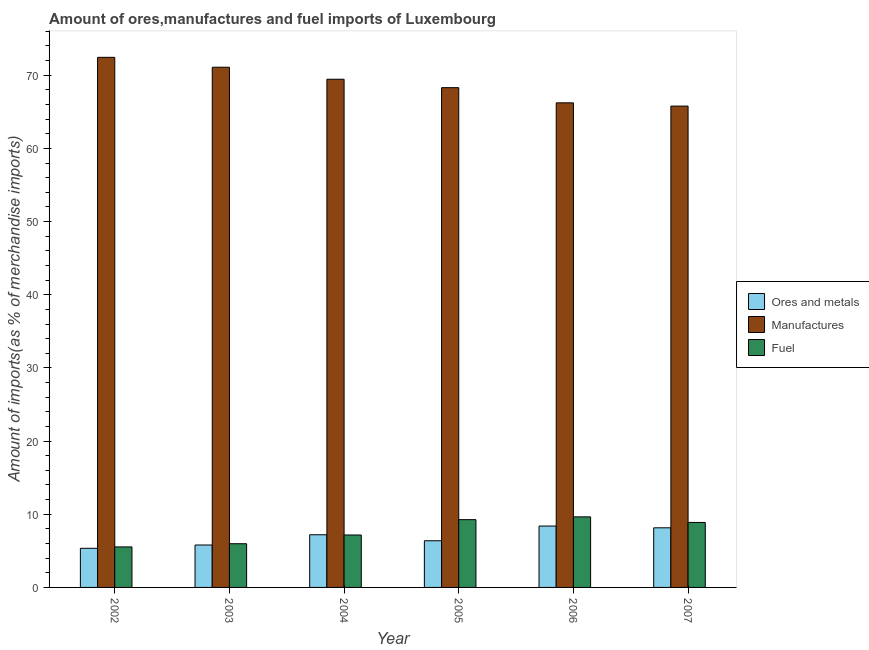How many different coloured bars are there?
Your answer should be very brief. 3. Are the number of bars per tick equal to the number of legend labels?
Your response must be concise. Yes. Are the number of bars on each tick of the X-axis equal?
Provide a short and direct response. Yes. How many bars are there on the 3rd tick from the left?
Offer a terse response. 3. How many bars are there on the 1st tick from the right?
Provide a succinct answer. 3. What is the percentage of manufactures imports in 2002?
Make the answer very short. 72.45. Across all years, what is the maximum percentage of manufactures imports?
Your response must be concise. 72.45. Across all years, what is the minimum percentage of manufactures imports?
Ensure brevity in your answer.  65.79. In which year was the percentage of ores and metals imports maximum?
Your answer should be compact. 2006. In which year was the percentage of ores and metals imports minimum?
Your answer should be compact. 2002. What is the total percentage of manufactures imports in the graph?
Ensure brevity in your answer.  413.32. What is the difference between the percentage of ores and metals imports in 2004 and that in 2006?
Make the answer very short. -1.19. What is the difference between the percentage of ores and metals imports in 2006 and the percentage of manufactures imports in 2004?
Offer a very short reply. 1.19. What is the average percentage of manufactures imports per year?
Your answer should be very brief. 68.89. What is the ratio of the percentage of fuel imports in 2003 to that in 2005?
Keep it short and to the point. 0.64. Is the percentage of ores and metals imports in 2004 less than that in 2007?
Keep it short and to the point. Yes. What is the difference between the highest and the second highest percentage of ores and metals imports?
Provide a short and direct response. 0.24. What is the difference between the highest and the lowest percentage of ores and metals imports?
Make the answer very short. 3.04. In how many years, is the percentage of ores and metals imports greater than the average percentage of ores and metals imports taken over all years?
Offer a terse response. 3. What does the 1st bar from the left in 2004 represents?
Make the answer very short. Ores and metals. What does the 1st bar from the right in 2004 represents?
Offer a terse response. Fuel. Are all the bars in the graph horizontal?
Your answer should be compact. No. Are the values on the major ticks of Y-axis written in scientific E-notation?
Offer a very short reply. No. Where does the legend appear in the graph?
Offer a terse response. Center right. How many legend labels are there?
Provide a succinct answer. 3. What is the title of the graph?
Offer a very short reply. Amount of ores,manufactures and fuel imports of Luxembourg. What is the label or title of the Y-axis?
Provide a short and direct response. Amount of imports(as % of merchandise imports). What is the Amount of imports(as % of merchandise imports) of Ores and metals in 2002?
Offer a very short reply. 5.35. What is the Amount of imports(as % of merchandise imports) of Manufactures in 2002?
Provide a succinct answer. 72.45. What is the Amount of imports(as % of merchandise imports) of Fuel in 2002?
Ensure brevity in your answer.  5.54. What is the Amount of imports(as % of merchandise imports) in Ores and metals in 2003?
Offer a terse response. 5.8. What is the Amount of imports(as % of merchandise imports) in Manufactures in 2003?
Offer a very short reply. 71.1. What is the Amount of imports(as % of merchandise imports) in Fuel in 2003?
Provide a succinct answer. 5.97. What is the Amount of imports(as % of merchandise imports) in Ores and metals in 2004?
Provide a short and direct response. 7.2. What is the Amount of imports(as % of merchandise imports) of Manufactures in 2004?
Your answer should be compact. 69.45. What is the Amount of imports(as % of merchandise imports) in Fuel in 2004?
Your response must be concise. 7.17. What is the Amount of imports(as % of merchandise imports) in Ores and metals in 2005?
Ensure brevity in your answer.  6.38. What is the Amount of imports(as % of merchandise imports) of Manufactures in 2005?
Offer a terse response. 68.3. What is the Amount of imports(as % of merchandise imports) of Fuel in 2005?
Your answer should be compact. 9.26. What is the Amount of imports(as % of merchandise imports) in Ores and metals in 2006?
Provide a short and direct response. 8.39. What is the Amount of imports(as % of merchandise imports) in Manufactures in 2006?
Your answer should be very brief. 66.23. What is the Amount of imports(as % of merchandise imports) of Fuel in 2006?
Provide a succinct answer. 9.64. What is the Amount of imports(as % of merchandise imports) of Ores and metals in 2007?
Keep it short and to the point. 8.15. What is the Amount of imports(as % of merchandise imports) in Manufactures in 2007?
Your response must be concise. 65.79. What is the Amount of imports(as % of merchandise imports) of Fuel in 2007?
Give a very brief answer. 8.88. Across all years, what is the maximum Amount of imports(as % of merchandise imports) of Ores and metals?
Keep it short and to the point. 8.39. Across all years, what is the maximum Amount of imports(as % of merchandise imports) in Manufactures?
Your response must be concise. 72.45. Across all years, what is the maximum Amount of imports(as % of merchandise imports) of Fuel?
Offer a very short reply. 9.64. Across all years, what is the minimum Amount of imports(as % of merchandise imports) of Ores and metals?
Your answer should be compact. 5.35. Across all years, what is the minimum Amount of imports(as % of merchandise imports) in Manufactures?
Make the answer very short. 65.79. Across all years, what is the minimum Amount of imports(as % of merchandise imports) of Fuel?
Make the answer very short. 5.54. What is the total Amount of imports(as % of merchandise imports) of Ores and metals in the graph?
Provide a succinct answer. 41.26. What is the total Amount of imports(as % of merchandise imports) in Manufactures in the graph?
Offer a terse response. 413.32. What is the total Amount of imports(as % of merchandise imports) in Fuel in the graph?
Give a very brief answer. 46.47. What is the difference between the Amount of imports(as % of merchandise imports) in Ores and metals in 2002 and that in 2003?
Your answer should be compact. -0.45. What is the difference between the Amount of imports(as % of merchandise imports) of Manufactures in 2002 and that in 2003?
Your answer should be compact. 1.35. What is the difference between the Amount of imports(as % of merchandise imports) in Fuel in 2002 and that in 2003?
Your answer should be compact. -0.44. What is the difference between the Amount of imports(as % of merchandise imports) of Ores and metals in 2002 and that in 2004?
Provide a short and direct response. -1.85. What is the difference between the Amount of imports(as % of merchandise imports) in Manufactures in 2002 and that in 2004?
Give a very brief answer. 2.99. What is the difference between the Amount of imports(as % of merchandise imports) of Fuel in 2002 and that in 2004?
Give a very brief answer. -1.63. What is the difference between the Amount of imports(as % of merchandise imports) in Ores and metals in 2002 and that in 2005?
Make the answer very short. -1.03. What is the difference between the Amount of imports(as % of merchandise imports) in Manufactures in 2002 and that in 2005?
Provide a short and direct response. 4.15. What is the difference between the Amount of imports(as % of merchandise imports) of Fuel in 2002 and that in 2005?
Your answer should be very brief. -3.73. What is the difference between the Amount of imports(as % of merchandise imports) of Ores and metals in 2002 and that in 2006?
Make the answer very short. -3.04. What is the difference between the Amount of imports(as % of merchandise imports) in Manufactures in 2002 and that in 2006?
Make the answer very short. 6.22. What is the difference between the Amount of imports(as % of merchandise imports) of Fuel in 2002 and that in 2006?
Provide a succinct answer. -4.11. What is the difference between the Amount of imports(as % of merchandise imports) of Ores and metals in 2002 and that in 2007?
Keep it short and to the point. -2.8. What is the difference between the Amount of imports(as % of merchandise imports) in Manufactures in 2002 and that in 2007?
Ensure brevity in your answer.  6.66. What is the difference between the Amount of imports(as % of merchandise imports) of Fuel in 2002 and that in 2007?
Offer a terse response. -3.34. What is the difference between the Amount of imports(as % of merchandise imports) in Ores and metals in 2003 and that in 2004?
Make the answer very short. -1.4. What is the difference between the Amount of imports(as % of merchandise imports) in Manufactures in 2003 and that in 2004?
Keep it short and to the point. 1.64. What is the difference between the Amount of imports(as % of merchandise imports) of Fuel in 2003 and that in 2004?
Your answer should be very brief. -1.19. What is the difference between the Amount of imports(as % of merchandise imports) in Ores and metals in 2003 and that in 2005?
Keep it short and to the point. -0.58. What is the difference between the Amount of imports(as % of merchandise imports) in Manufactures in 2003 and that in 2005?
Make the answer very short. 2.79. What is the difference between the Amount of imports(as % of merchandise imports) of Fuel in 2003 and that in 2005?
Offer a very short reply. -3.29. What is the difference between the Amount of imports(as % of merchandise imports) of Ores and metals in 2003 and that in 2006?
Offer a terse response. -2.59. What is the difference between the Amount of imports(as % of merchandise imports) of Manufactures in 2003 and that in 2006?
Offer a very short reply. 4.87. What is the difference between the Amount of imports(as % of merchandise imports) of Fuel in 2003 and that in 2006?
Make the answer very short. -3.67. What is the difference between the Amount of imports(as % of merchandise imports) of Ores and metals in 2003 and that in 2007?
Offer a terse response. -2.35. What is the difference between the Amount of imports(as % of merchandise imports) of Manufactures in 2003 and that in 2007?
Offer a terse response. 5.31. What is the difference between the Amount of imports(as % of merchandise imports) of Fuel in 2003 and that in 2007?
Provide a succinct answer. -2.91. What is the difference between the Amount of imports(as % of merchandise imports) in Ores and metals in 2004 and that in 2005?
Your answer should be compact. 0.82. What is the difference between the Amount of imports(as % of merchandise imports) in Manufactures in 2004 and that in 2005?
Your response must be concise. 1.15. What is the difference between the Amount of imports(as % of merchandise imports) in Fuel in 2004 and that in 2005?
Your answer should be very brief. -2.1. What is the difference between the Amount of imports(as % of merchandise imports) of Ores and metals in 2004 and that in 2006?
Offer a very short reply. -1.19. What is the difference between the Amount of imports(as % of merchandise imports) of Manufactures in 2004 and that in 2006?
Give a very brief answer. 3.22. What is the difference between the Amount of imports(as % of merchandise imports) in Fuel in 2004 and that in 2006?
Offer a very short reply. -2.48. What is the difference between the Amount of imports(as % of merchandise imports) of Ores and metals in 2004 and that in 2007?
Offer a very short reply. -0.95. What is the difference between the Amount of imports(as % of merchandise imports) of Manufactures in 2004 and that in 2007?
Keep it short and to the point. 3.67. What is the difference between the Amount of imports(as % of merchandise imports) in Fuel in 2004 and that in 2007?
Ensure brevity in your answer.  -1.71. What is the difference between the Amount of imports(as % of merchandise imports) in Ores and metals in 2005 and that in 2006?
Your response must be concise. -2.01. What is the difference between the Amount of imports(as % of merchandise imports) in Manufactures in 2005 and that in 2006?
Your answer should be compact. 2.07. What is the difference between the Amount of imports(as % of merchandise imports) in Fuel in 2005 and that in 2006?
Provide a short and direct response. -0.38. What is the difference between the Amount of imports(as % of merchandise imports) of Ores and metals in 2005 and that in 2007?
Your answer should be compact. -1.77. What is the difference between the Amount of imports(as % of merchandise imports) in Manufactures in 2005 and that in 2007?
Your response must be concise. 2.52. What is the difference between the Amount of imports(as % of merchandise imports) in Fuel in 2005 and that in 2007?
Provide a short and direct response. 0.38. What is the difference between the Amount of imports(as % of merchandise imports) in Ores and metals in 2006 and that in 2007?
Provide a succinct answer. 0.24. What is the difference between the Amount of imports(as % of merchandise imports) in Manufactures in 2006 and that in 2007?
Your response must be concise. 0.44. What is the difference between the Amount of imports(as % of merchandise imports) of Fuel in 2006 and that in 2007?
Ensure brevity in your answer.  0.76. What is the difference between the Amount of imports(as % of merchandise imports) of Ores and metals in 2002 and the Amount of imports(as % of merchandise imports) of Manufactures in 2003?
Ensure brevity in your answer.  -65.75. What is the difference between the Amount of imports(as % of merchandise imports) of Ores and metals in 2002 and the Amount of imports(as % of merchandise imports) of Fuel in 2003?
Offer a terse response. -0.63. What is the difference between the Amount of imports(as % of merchandise imports) in Manufactures in 2002 and the Amount of imports(as % of merchandise imports) in Fuel in 2003?
Offer a terse response. 66.48. What is the difference between the Amount of imports(as % of merchandise imports) in Ores and metals in 2002 and the Amount of imports(as % of merchandise imports) in Manufactures in 2004?
Your answer should be compact. -64.11. What is the difference between the Amount of imports(as % of merchandise imports) of Ores and metals in 2002 and the Amount of imports(as % of merchandise imports) of Fuel in 2004?
Provide a short and direct response. -1.82. What is the difference between the Amount of imports(as % of merchandise imports) of Manufactures in 2002 and the Amount of imports(as % of merchandise imports) of Fuel in 2004?
Offer a terse response. 65.28. What is the difference between the Amount of imports(as % of merchandise imports) in Ores and metals in 2002 and the Amount of imports(as % of merchandise imports) in Manufactures in 2005?
Provide a succinct answer. -62.96. What is the difference between the Amount of imports(as % of merchandise imports) of Ores and metals in 2002 and the Amount of imports(as % of merchandise imports) of Fuel in 2005?
Your answer should be compact. -3.92. What is the difference between the Amount of imports(as % of merchandise imports) of Manufactures in 2002 and the Amount of imports(as % of merchandise imports) of Fuel in 2005?
Your answer should be very brief. 63.19. What is the difference between the Amount of imports(as % of merchandise imports) in Ores and metals in 2002 and the Amount of imports(as % of merchandise imports) in Manufactures in 2006?
Provide a short and direct response. -60.88. What is the difference between the Amount of imports(as % of merchandise imports) of Ores and metals in 2002 and the Amount of imports(as % of merchandise imports) of Fuel in 2006?
Make the answer very short. -4.3. What is the difference between the Amount of imports(as % of merchandise imports) in Manufactures in 2002 and the Amount of imports(as % of merchandise imports) in Fuel in 2006?
Make the answer very short. 62.81. What is the difference between the Amount of imports(as % of merchandise imports) in Ores and metals in 2002 and the Amount of imports(as % of merchandise imports) in Manufactures in 2007?
Your response must be concise. -60.44. What is the difference between the Amount of imports(as % of merchandise imports) of Ores and metals in 2002 and the Amount of imports(as % of merchandise imports) of Fuel in 2007?
Ensure brevity in your answer.  -3.54. What is the difference between the Amount of imports(as % of merchandise imports) in Manufactures in 2002 and the Amount of imports(as % of merchandise imports) in Fuel in 2007?
Your answer should be very brief. 63.57. What is the difference between the Amount of imports(as % of merchandise imports) in Ores and metals in 2003 and the Amount of imports(as % of merchandise imports) in Manufactures in 2004?
Your response must be concise. -63.66. What is the difference between the Amount of imports(as % of merchandise imports) in Ores and metals in 2003 and the Amount of imports(as % of merchandise imports) in Fuel in 2004?
Offer a very short reply. -1.37. What is the difference between the Amount of imports(as % of merchandise imports) of Manufactures in 2003 and the Amount of imports(as % of merchandise imports) of Fuel in 2004?
Keep it short and to the point. 63.93. What is the difference between the Amount of imports(as % of merchandise imports) of Ores and metals in 2003 and the Amount of imports(as % of merchandise imports) of Manufactures in 2005?
Provide a short and direct response. -62.51. What is the difference between the Amount of imports(as % of merchandise imports) of Ores and metals in 2003 and the Amount of imports(as % of merchandise imports) of Fuel in 2005?
Offer a terse response. -3.47. What is the difference between the Amount of imports(as % of merchandise imports) in Manufactures in 2003 and the Amount of imports(as % of merchandise imports) in Fuel in 2005?
Give a very brief answer. 61.83. What is the difference between the Amount of imports(as % of merchandise imports) of Ores and metals in 2003 and the Amount of imports(as % of merchandise imports) of Manufactures in 2006?
Ensure brevity in your answer.  -60.43. What is the difference between the Amount of imports(as % of merchandise imports) in Ores and metals in 2003 and the Amount of imports(as % of merchandise imports) in Fuel in 2006?
Ensure brevity in your answer.  -3.85. What is the difference between the Amount of imports(as % of merchandise imports) in Manufactures in 2003 and the Amount of imports(as % of merchandise imports) in Fuel in 2006?
Offer a terse response. 61.45. What is the difference between the Amount of imports(as % of merchandise imports) of Ores and metals in 2003 and the Amount of imports(as % of merchandise imports) of Manufactures in 2007?
Provide a succinct answer. -59.99. What is the difference between the Amount of imports(as % of merchandise imports) in Ores and metals in 2003 and the Amount of imports(as % of merchandise imports) in Fuel in 2007?
Your response must be concise. -3.08. What is the difference between the Amount of imports(as % of merchandise imports) of Manufactures in 2003 and the Amount of imports(as % of merchandise imports) of Fuel in 2007?
Ensure brevity in your answer.  62.22. What is the difference between the Amount of imports(as % of merchandise imports) in Ores and metals in 2004 and the Amount of imports(as % of merchandise imports) in Manufactures in 2005?
Offer a terse response. -61.1. What is the difference between the Amount of imports(as % of merchandise imports) of Ores and metals in 2004 and the Amount of imports(as % of merchandise imports) of Fuel in 2005?
Give a very brief answer. -2.06. What is the difference between the Amount of imports(as % of merchandise imports) of Manufactures in 2004 and the Amount of imports(as % of merchandise imports) of Fuel in 2005?
Give a very brief answer. 60.19. What is the difference between the Amount of imports(as % of merchandise imports) of Ores and metals in 2004 and the Amount of imports(as % of merchandise imports) of Manufactures in 2006?
Ensure brevity in your answer.  -59.03. What is the difference between the Amount of imports(as % of merchandise imports) in Ores and metals in 2004 and the Amount of imports(as % of merchandise imports) in Fuel in 2006?
Your response must be concise. -2.45. What is the difference between the Amount of imports(as % of merchandise imports) in Manufactures in 2004 and the Amount of imports(as % of merchandise imports) in Fuel in 2006?
Keep it short and to the point. 59.81. What is the difference between the Amount of imports(as % of merchandise imports) of Ores and metals in 2004 and the Amount of imports(as % of merchandise imports) of Manufactures in 2007?
Make the answer very short. -58.59. What is the difference between the Amount of imports(as % of merchandise imports) in Ores and metals in 2004 and the Amount of imports(as % of merchandise imports) in Fuel in 2007?
Your response must be concise. -1.68. What is the difference between the Amount of imports(as % of merchandise imports) of Manufactures in 2004 and the Amount of imports(as % of merchandise imports) of Fuel in 2007?
Ensure brevity in your answer.  60.57. What is the difference between the Amount of imports(as % of merchandise imports) in Ores and metals in 2005 and the Amount of imports(as % of merchandise imports) in Manufactures in 2006?
Keep it short and to the point. -59.85. What is the difference between the Amount of imports(as % of merchandise imports) in Ores and metals in 2005 and the Amount of imports(as % of merchandise imports) in Fuel in 2006?
Provide a succinct answer. -3.27. What is the difference between the Amount of imports(as % of merchandise imports) of Manufactures in 2005 and the Amount of imports(as % of merchandise imports) of Fuel in 2006?
Your answer should be very brief. 58.66. What is the difference between the Amount of imports(as % of merchandise imports) of Ores and metals in 2005 and the Amount of imports(as % of merchandise imports) of Manufactures in 2007?
Offer a very short reply. -59.41. What is the difference between the Amount of imports(as % of merchandise imports) in Ores and metals in 2005 and the Amount of imports(as % of merchandise imports) in Fuel in 2007?
Your response must be concise. -2.5. What is the difference between the Amount of imports(as % of merchandise imports) of Manufactures in 2005 and the Amount of imports(as % of merchandise imports) of Fuel in 2007?
Give a very brief answer. 59.42. What is the difference between the Amount of imports(as % of merchandise imports) in Ores and metals in 2006 and the Amount of imports(as % of merchandise imports) in Manufactures in 2007?
Your response must be concise. -57.4. What is the difference between the Amount of imports(as % of merchandise imports) of Ores and metals in 2006 and the Amount of imports(as % of merchandise imports) of Fuel in 2007?
Keep it short and to the point. -0.49. What is the difference between the Amount of imports(as % of merchandise imports) in Manufactures in 2006 and the Amount of imports(as % of merchandise imports) in Fuel in 2007?
Ensure brevity in your answer.  57.35. What is the average Amount of imports(as % of merchandise imports) of Ores and metals per year?
Give a very brief answer. 6.88. What is the average Amount of imports(as % of merchandise imports) of Manufactures per year?
Keep it short and to the point. 68.89. What is the average Amount of imports(as % of merchandise imports) of Fuel per year?
Provide a succinct answer. 7.74. In the year 2002, what is the difference between the Amount of imports(as % of merchandise imports) in Ores and metals and Amount of imports(as % of merchandise imports) in Manufactures?
Ensure brevity in your answer.  -67.1. In the year 2002, what is the difference between the Amount of imports(as % of merchandise imports) of Ores and metals and Amount of imports(as % of merchandise imports) of Fuel?
Offer a terse response. -0.19. In the year 2002, what is the difference between the Amount of imports(as % of merchandise imports) in Manufactures and Amount of imports(as % of merchandise imports) in Fuel?
Provide a succinct answer. 66.91. In the year 2003, what is the difference between the Amount of imports(as % of merchandise imports) in Ores and metals and Amount of imports(as % of merchandise imports) in Manufactures?
Offer a very short reply. -65.3. In the year 2003, what is the difference between the Amount of imports(as % of merchandise imports) of Ores and metals and Amount of imports(as % of merchandise imports) of Fuel?
Offer a terse response. -0.18. In the year 2003, what is the difference between the Amount of imports(as % of merchandise imports) of Manufactures and Amount of imports(as % of merchandise imports) of Fuel?
Make the answer very short. 65.12. In the year 2004, what is the difference between the Amount of imports(as % of merchandise imports) in Ores and metals and Amount of imports(as % of merchandise imports) in Manufactures?
Your response must be concise. -62.26. In the year 2004, what is the difference between the Amount of imports(as % of merchandise imports) in Ores and metals and Amount of imports(as % of merchandise imports) in Fuel?
Offer a terse response. 0.03. In the year 2004, what is the difference between the Amount of imports(as % of merchandise imports) in Manufactures and Amount of imports(as % of merchandise imports) in Fuel?
Your answer should be very brief. 62.29. In the year 2005, what is the difference between the Amount of imports(as % of merchandise imports) in Ores and metals and Amount of imports(as % of merchandise imports) in Manufactures?
Offer a terse response. -61.93. In the year 2005, what is the difference between the Amount of imports(as % of merchandise imports) of Ores and metals and Amount of imports(as % of merchandise imports) of Fuel?
Ensure brevity in your answer.  -2.89. In the year 2005, what is the difference between the Amount of imports(as % of merchandise imports) of Manufactures and Amount of imports(as % of merchandise imports) of Fuel?
Provide a short and direct response. 59.04. In the year 2006, what is the difference between the Amount of imports(as % of merchandise imports) in Ores and metals and Amount of imports(as % of merchandise imports) in Manufactures?
Provide a short and direct response. -57.84. In the year 2006, what is the difference between the Amount of imports(as % of merchandise imports) of Ores and metals and Amount of imports(as % of merchandise imports) of Fuel?
Provide a succinct answer. -1.26. In the year 2006, what is the difference between the Amount of imports(as % of merchandise imports) in Manufactures and Amount of imports(as % of merchandise imports) in Fuel?
Provide a short and direct response. 56.59. In the year 2007, what is the difference between the Amount of imports(as % of merchandise imports) of Ores and metals and Amount of imports(as % of merchandise imports) of Manufactures?
Provide a short and direct response. -57.64. In the year 2007, what is the difference between the Amount of imports(as % of merchandise imports) of Ores and metals and Amount of imports(as % of merchandise imports) of Fuel?
Offer a very short reply. -0.73. In the year 2007, what is the difference between the Amount of imports(as % of merchandise imports) of Manufactures and Amount of imports(as % of merchandise imports) of Fuel?
Offer a very short reply. 56.9. What is the ratio of the Amount of imports(as % of merchandise imports) of Ores and metals in 2002 to that in 2003?
Offer a terse response. 0.92. What is the ratio of the Amount of imports(as % of merchandise imports) in Manufactures in 2002 to that in 2003?
Offer a terse response. 1.02. What is the ratio of the Amount of imports(as % of merchandise imports) of Fuel in 2002 to that in 2003?
Offer a very short reply. 0.93. What is the ratio of the Amount of imports(as % of merchandise imports) in Ores and metals in 2002 to that in 2004?
Your answer should be compact. 0.74. What is the ratio of the Amount of imports(as % of merchandise imports) of Manufactures in 2002 to that in 2004?
Your answer should be very brief. 1.04. What is the ratio of the Amount of imports(as % of merchandise imports) of Fuel in 2002 to that in 2004?
Offer a very short reply. 0.77. What is the ratio of the Amount of imports(as % of merchandise imports) in Ores and metals in 2002 to that in 2005?
Provide a succinct answer. 0.84. What is the ratio of the Amount of imports(as % of merchandise imports) of Manufactures in 2002 to that in 2005?
Offer a terse response. 1.06. What is the ratio of the Amount of imports(as % of merchandise imports) in Fuel in 2002 to that in 2005?
Ensure brevity in your answer.  0.6. What is the ratio of the Amount of imports(as % of merchandise imports) in Ores and metals in 2002 to that in 2006?
Provide a short and direct response. 0.64. What is the ratio of the Amount of imports(as % of merchandise imports) in Manufactures in 2002 to that in 2006?
Your answer should be compact. 1.09. What is the ratio of the Amount of imports(as % of merchandise imports) in Fuel in 2002 to that in 2006?
Your answer should be very brief. 0.57. What is the ratio of the Amount of imports(as % of merchandise imports) in Ores and metals in 2002 to that in 2007?
Make the answer very short. 0.66. What is the ratio of the Amount of imports(as % of merchandise imports) of Manufactures in 2002 to that in 2007?
Provide a short and direct response. 1.1. What is the ratio of the Amount of imports(as % of merchandise imports) in Fuel in 2002 to that in 2007?
Your answer should be very brief. 0.62. What is the ratio of the Amount of imports(as % of merchandise imports) of Ores and metals in 2003 to that in 2004?
Your answer should be very brief. 0.81. What is the ratio of the Amount of imports(as % of merchandise imports) in Manufactures in 2003 to that in 2004?
Ensure brevity in your answer.  1.02. What is the ratio of the Amount of imports(as % of merchandise imports) in Fuel in 2003 to that in 2004?
Give a very brief answer. 0.83. What is the ratio of the Amount of imports(as % of merchandise imports) in Ores and metals in 2003 to that in 2005?
Your answer should be compact. 0.91. What is the ratio of the Amount of imports(as % of merchandise imports) in Manufactures in 2003 to that in 2005?
Offer a very short reply. 1.04. What is the ratio of the Amount of imports(as % of merchandise imports) of Fuel in 2003 to that in 2005?
Offer a terse response. 0.64. What is the ratio of the Amount of imports(as % of merchandise imports) of Ores and metals in 2003 to that in 2006?
Offer a very short reply. 0.69. What is the ratio of the Amount of imports(as % of merchandise imports) in Manufactures in 2003 to that in 2006?
Ensure brevity in your answer.  1.07. What is the ratio of the Amount of imports(as % of merchandise imports) of Fuel in 2003 to that in 2006?
Ensure brevity in your answer.  0.62. What is the ratio of the Amount of imports(as % of merchandise imports) in Ores and metals in 2003 to that in 2007?
Provide a succinct answer. 0.71. What is the ratio of the Amount of imports(as % of merchandise imports) in Manufactures in 2003 to that in 2007?
Offer a terse response. 1.08. What is the ratio of the Amount of imports(as % of merchandise imports) of Fuel in 2003 to that in 2007?
Ensure brevity in your answer.  0.67. What is the ratio of the Amount of imports(as % of merchandise imports) of Ores and metals in 2004 to that in 2005?
Your response must be concise. 1.13. What is the ratio of the Amount of imports(as % of merchandise imports) in Manufactures in 2004 to that in 2005?
Provide a short and direct response. 1.02. What is the ratio of the Amount of imports(as % of merchandise imports) in Fuel in 2004 to that in 2005?
Your answer should be very brief. 0.77. What is the ratio of the Amount of imports(as % of merchandise imports) in Ores and metals in 2004 to that in 2006?
Your answer should be compact. 0.86. What is the ratio of the Amount of imports(as % of merchandise imports) in Manufactures in 2004 to that in 2006?
Offer a terse response. 1.05. What is the ratio of the Amount of imports(as % of merchandise imports) in Fuel in 2004 to that in 2006?
Ensure brevity in your answer.  0.74. What is the ratio of the Amount of imports(as % of merchandise imports) in Ores and metals in 2004 to that in 2007?
Provide a succinct answer. 0.88. What is the ratio of the Amount of imports(as % of merchandise imports) of Manufactures in 2004 to that in 2007?
Provide a succinct answer. 1.06. What is the ratio of the Amount of imports(as % of merchandise imports) of Fuel in 2004 to that in 2007?
Offer a very short reply. 0.81. What is the ratio of the Amount of imports(as % of merchandise imports) in Ores and metals in 2005 to that in 2006?
Make the answer very short. 0.76. What is the ratio of the Amount of imports(as % of merchandise imports) of Manufactures in 2005 to that in 2006?
Provide a succinct answer. 1.03. What is the ratio of the Amount of imports(as % of merchandise imports) in Fuel in 2005 to that in 2006?
Ensure brevity in your answer.  0.96. What is the ratio of the Amount of imports(as % of merchandise imports) in Ores and metals in 2005 to that in 2007?
Provide a short and direct response. 0.78. What is the ratio of the Amount of imports(as % of merchandise imports) in Manufactures in 2005 to that in 2007?
Your answer should be compact. 1.04. What is the ratio of the Amount of imports(as % of merchandise imports) in Fuel in 2005 to that in 2007?
Keep it short and to the point. 1.04. What is the ratio of the Amount of imports(as % of merchandise imports) in Ores and metals in 2006 to that in 2007?
Offer a very short reply. 1.03. What is the ratio of the Amount of imports(as % of merchandise imports) in Manufactures in 2006 to that in 2007?
Keep it short and to the point. 1.01. What is the ratio of the Amount of imports(as % of merchandise imports) in Fuel in 2006 to that in 2007?
Provide a succinct answer. 1.09. What is the difference between the highest and the second highest Amount of imports(as % of merchandise imports) in Ores and metals?
Give a very brief answer. 0.24. What is the difference between the highest and the second highest Amount of imports(as % of merchandise imports) in Manufactures?
Your response must be concise. 1.35. What is the difference between the highest and the second highest Amount of imports(as % of merchandise imports) of Fuel?
Keep it short and to the point. 0.38. What is the difference between the highest and the lowest Amount of imports(as % of merchandise imports) in Ores and metals?
Provide a succinct answer. 3.04. What is the difference between the highest and the lowest Amount of imports(as % of merchandise imports) of Manufactures?
Make the answer very short. 6.66. What is the difference between the highest and the lowest Amount of imports(as % of merchandise imports) in Fuel?
Keep it short and to the point. 4.11. 